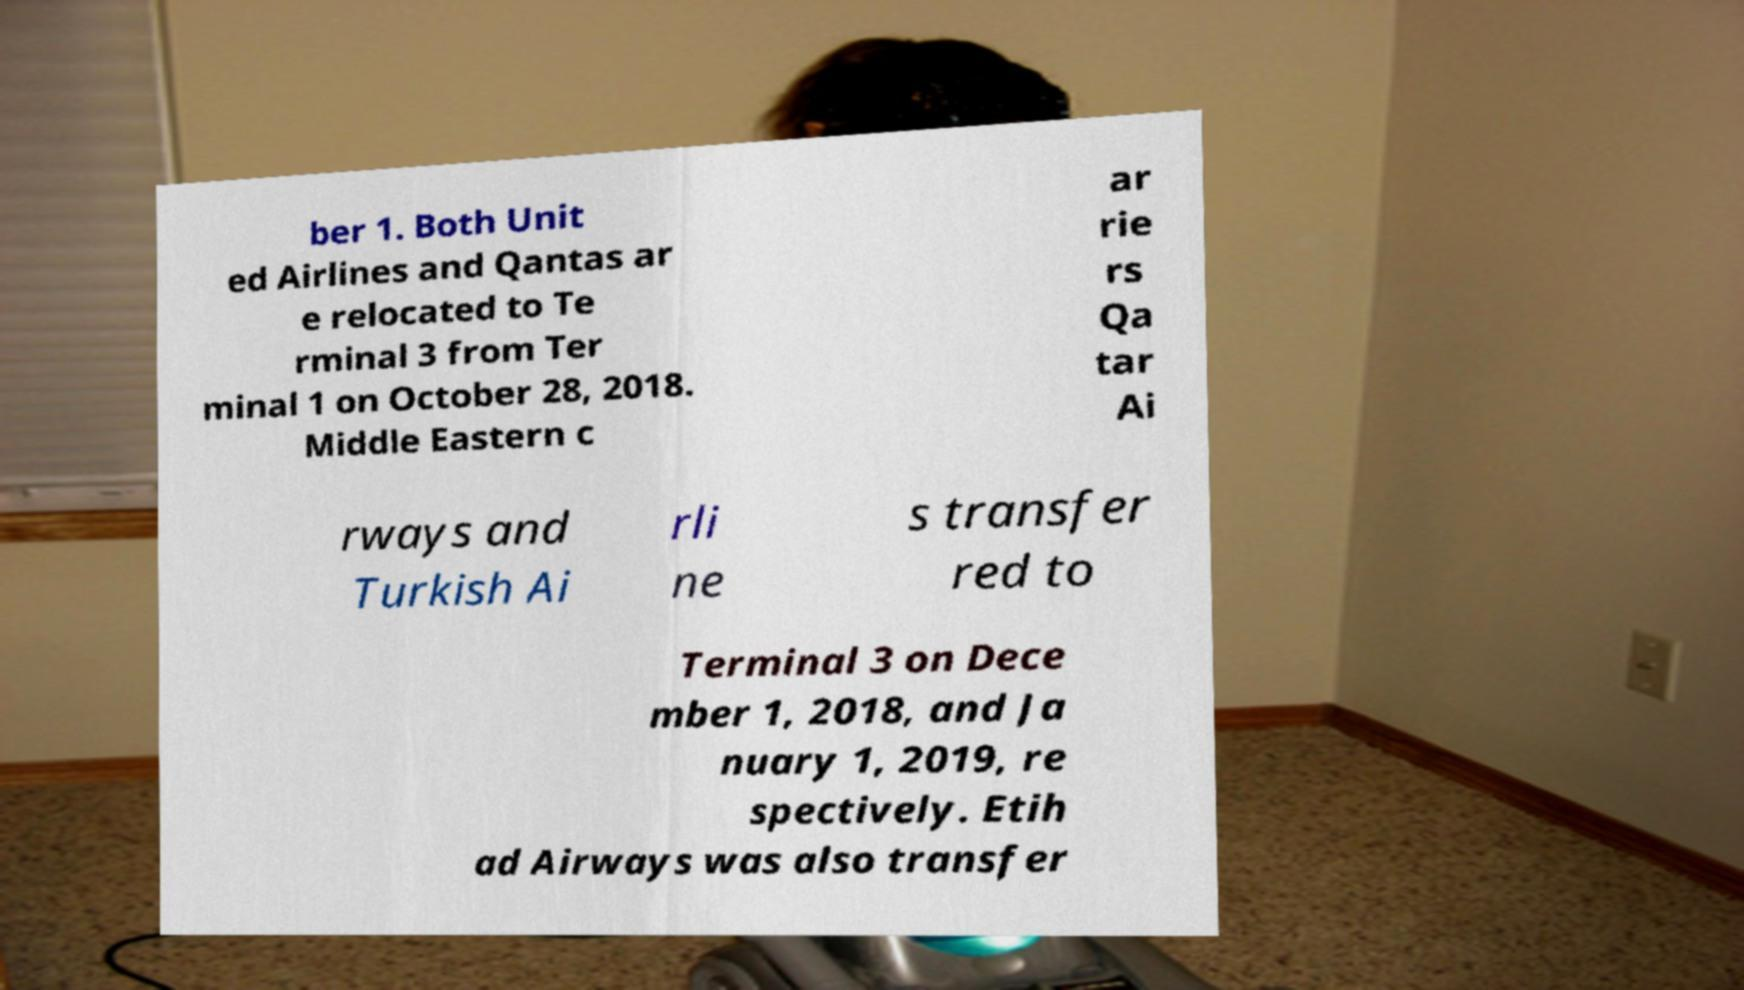For documentation purposes, I need the text within this image transcribed. Could you provide that? ber 1. Both Unit ed Airlines and Qantas ar e relocated to Te rminal 3 from Ter minal 1 on October 28, 2018. Middle Eastern c ar rie rs Qa tar Ai rways and Turkish Ai rli ne s transfer red to Terminal 3 on Dece mber 1, 2018, and Ja nuary 1, 2019, re spectively. Etih ad Airways was also transfer 